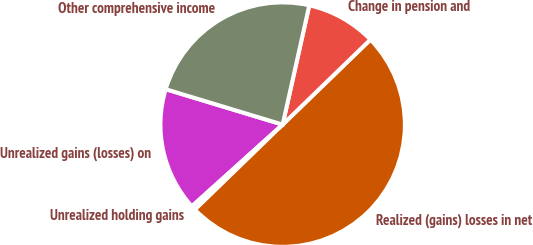Convert chart to OTSL. <chart><loc_0><loc_0><loc_500><loc_500><pie_chart><fcel>Unrealized gains (losses) on<fcel>Unrealized holding gains<fcel>Realized (gains) losses in net<fcel>Change in pension and<fcel>Other comprehensive income<nl><fcel>16.35%<fcel>0.58%<fcel>50.0%<fcel>9.26%<fcel>23.82%<nl></chart> 